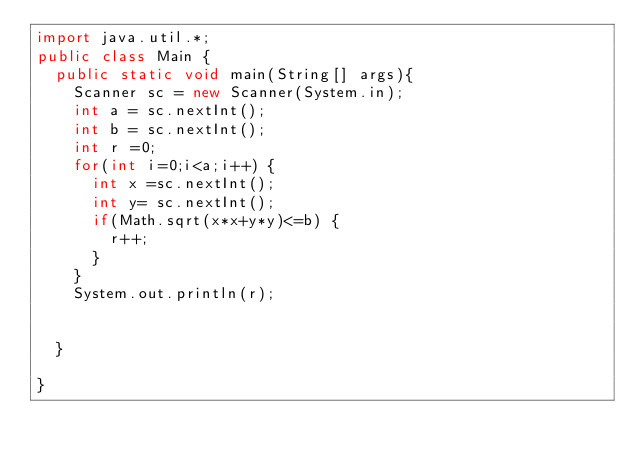Convert code to text. <code><loc_0><loc_0><loc_500><loc_500><_Java_>import java.util.*;
public class Main {
	public static void main(String[] args){
		Scanner sc = new Scanner(System.in);
		int a = sc.nextInt();
		int b = sc.nextInt();
		int r =0;
		for(int i=0;i<a;i++) {
			int x =sc.nextInt();
			int y= sc.nextInt();
			if(Math.sqrt(x*x+y*y)<=b) {
				r++;
			}
		}
		System.out.println(r);
		

	}

}



</code> 